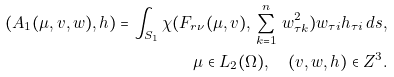Convert formula to latex. <formula><loc_0><loc_0><loc_500><loc_500>( A _ { 1 } ( \mu , v , w ) , h ) = \int _ { S _ { 1 } } \chi ( F _ { r \nu } ( \mu , v ) , \, \sum _ { k = 1 } ^ { n } \, w _ { \tau k } ^ { 2 } ) w _ { \tau i } h _ { \tau i } \, d s , \\ \mu \in L _ { 2 } ( \Omega ) , \quad ( v , w , h ) \in Z ^ { 3 } .</formula> 